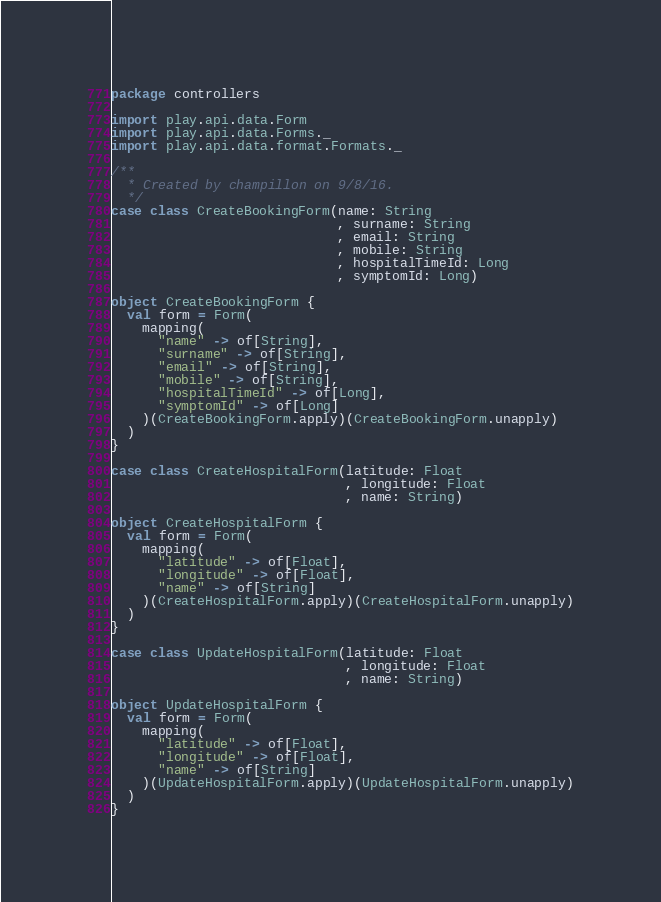<code> <loc_0><loc_0><loc_500><loc_500><_Scala_>package controllers

import play.api.data.Form
import play.api.data.Forms._
import play.api.data.format.Formats._

/**
  * Created by champillon on 9/8/16.
  */
case class CreateBookingForm(name: String
                             , surname: String
                             , email: String
                             , mobile: String
                             , hospitalTimeId: Long
                             , symptomId: Long)

object CreateBookingForm {
  val form = Form(
    mapping(
      "name" -> of[String],
      "surname" -> of[String],
      "email" -> of[String],
      "mobile" -> of[String],
      "hospitalTimeId" -> of[Long],
      "symptomId" -> of[Long]
    )(CreateBookingForm.apply)(CreateBookingForm.unapply)
  )
}

case class CreateHospitalForm(latitude: Float
                              , longitude: Float
                              , name: String)

object CreateHospitalForm {
  val form = Form(
    mapping(
      "latitude" -> of[Float],
      "longitude" -> of[Float],
      "name" -> of[String]
    )(CreateHospitalForm.apply)(CreateHospitalForm.unapply)
  )
}

case class UpdateHospitalForm(latitude: Float
                              , longitude: Float
                              , name: String)

object UpdateHospitalForm {
  val form = Form(
    mapping(
      "latitude" -> of[Float],
      "longitude" -> of[Float],
      "name" -> of[String]
    )(UpdateHospitalForm.apply)(UpdateHospitalForm.unapply)
  )
}</code> 